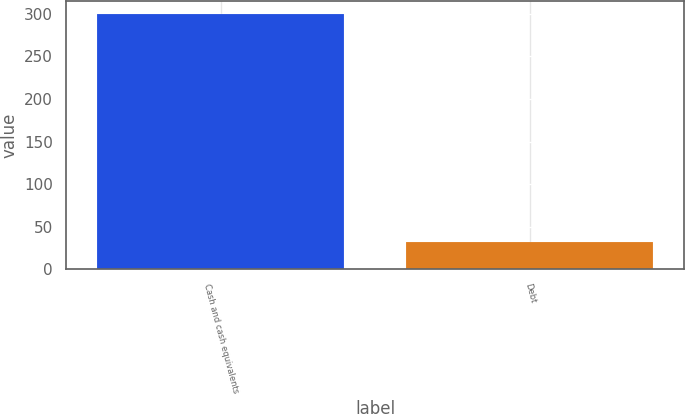Convert chart. <chart><loc_0><loc_0><loc_500><loc_500><bar_chart><fcel>Cash and cash equivalents<fcel>Debt<nl><fcel>299.8<fcel>32.6<nl></chart> 